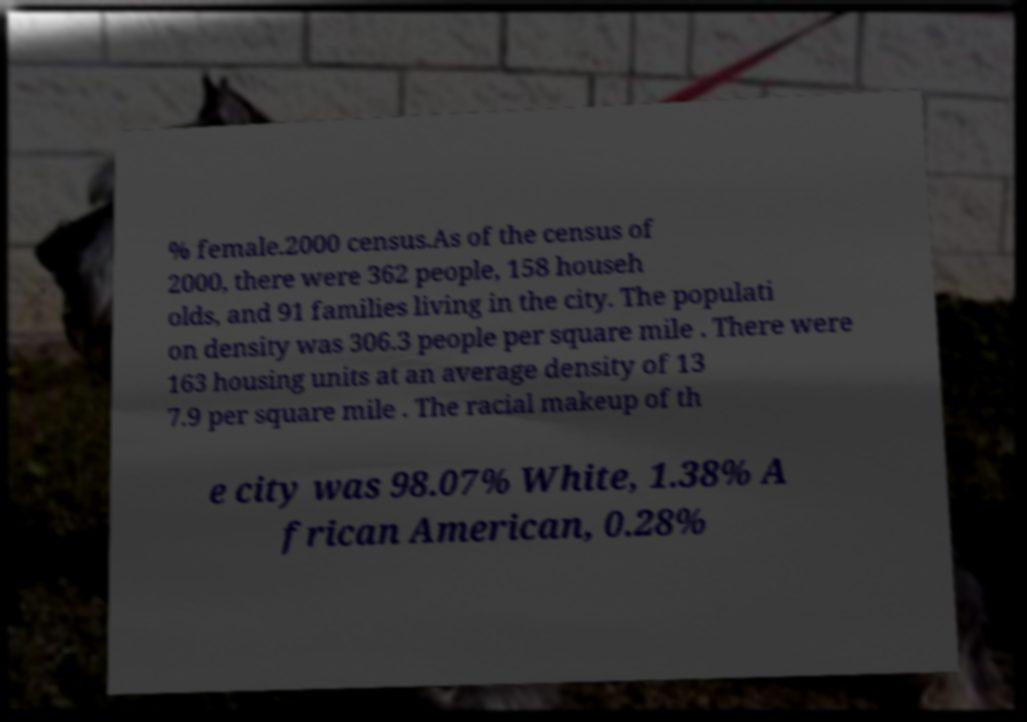Could you assist in decoding the text presented in this image and type it out clearly? % female.2000 census.As of the census of 2000, there were 362 people, 158 househ olds, and 91 families living in the city. The populati on density was 306.3 people per square mile . There were 163 housing units at an average density of 13 7.9 per square mile . The racial makeup of th e city was 98.07% White, 1.38% A frican American, 0.28% 